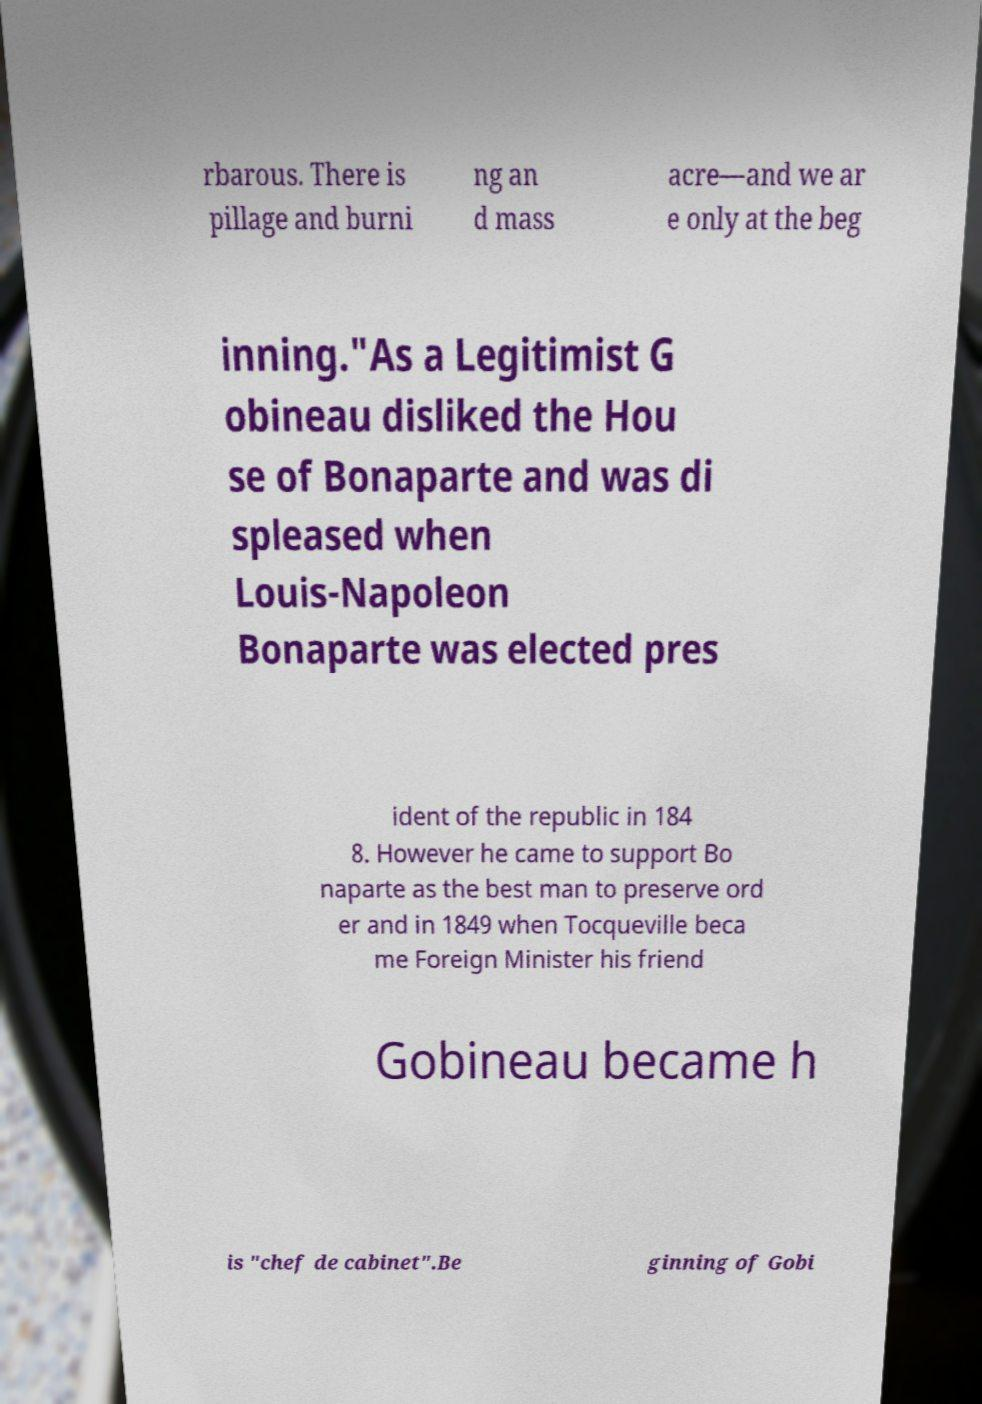Could you extract and type out the text from this image? rbarous. There is pillage and burni ng an d mass acre—and we ar e only at the beg inning."As a Legitimist G obineau disliked the Hou se of Bonaparte and was di spleased when Louis-Napoleon Bonaparte was elected pres ident of the republic in 184 8. However he came to support Bo naparte as the best man to preserve ord er and in 1849 when Tocqueville beca me Foreign Minister his friend Gobineau became h is "chef de cabinet".Be ginning of Gobi 